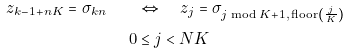<formula> <loc_0><loc_0><loc_500><loc_500>z _ { k - 1 + n K } = \sigma _ { k n } \quad & \Leftrightarrow \quad z _ { j } = \sigma _ { j \bmod K + 1 , \, \text {floor} \left ( \frac { j } { K } \right ) } \\ \quad 0 & \leq j < N K</formula> 